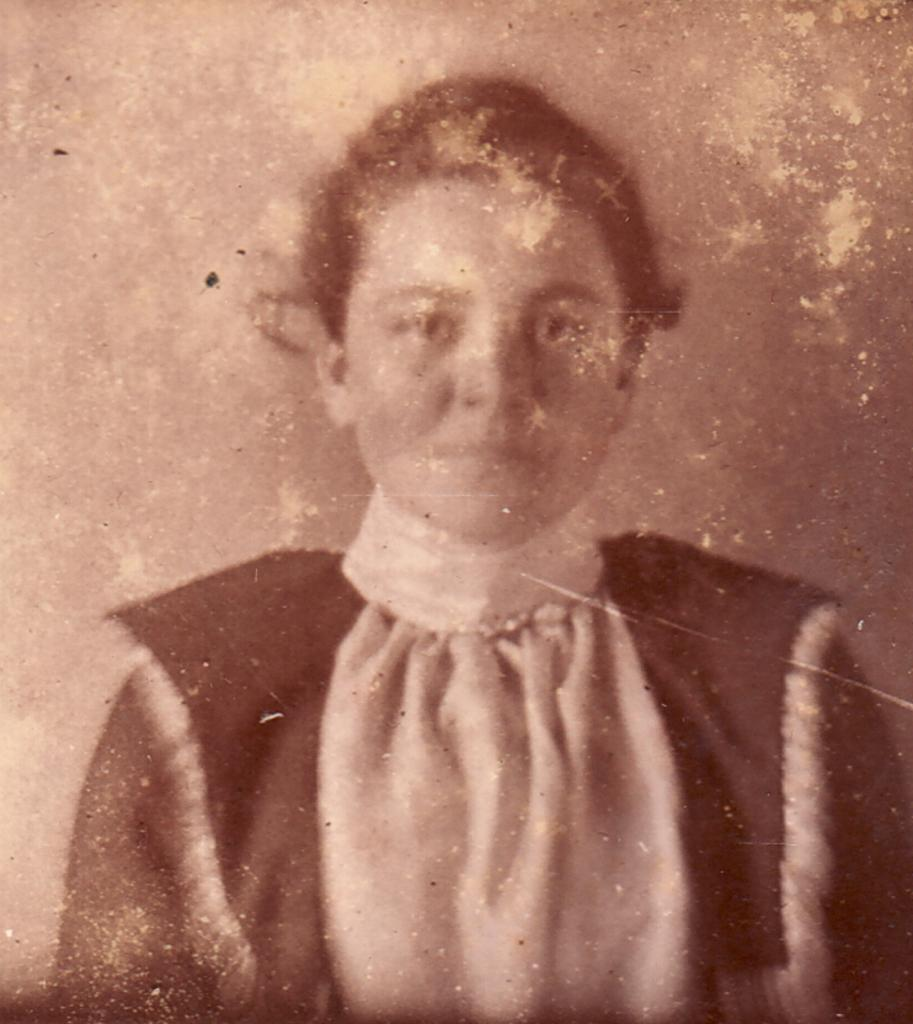What is present in the image? There is a person in the image. Can you describe the person's attire? The person is wearing clothes. What type of crate is being used to transport the vessel in the image? There is no crate or vessel present in the image; it only features a person wearing clothes. 